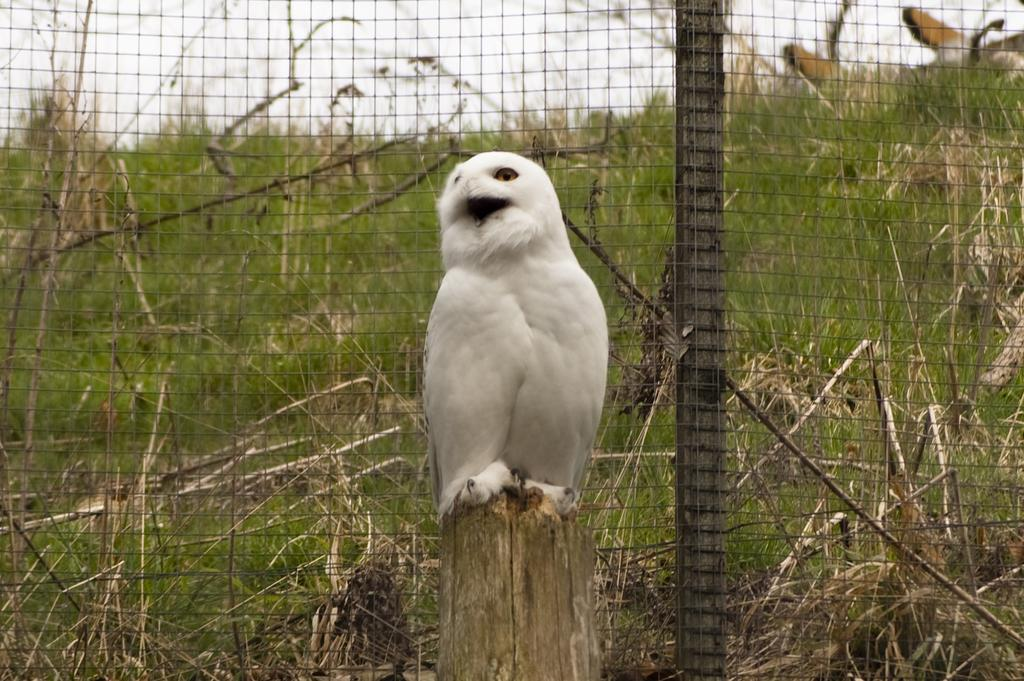What type of animal can be seen in the image? There is a bird in the image. Where is the bird located? The bird is on a wooden object. What can be seen in the background of the image? There is a mesh in the image, and grass, stems, and the sky are visible through it. What type of society does the bird belong to in the image? The image does not provide information about the bird's society or any social structures. 